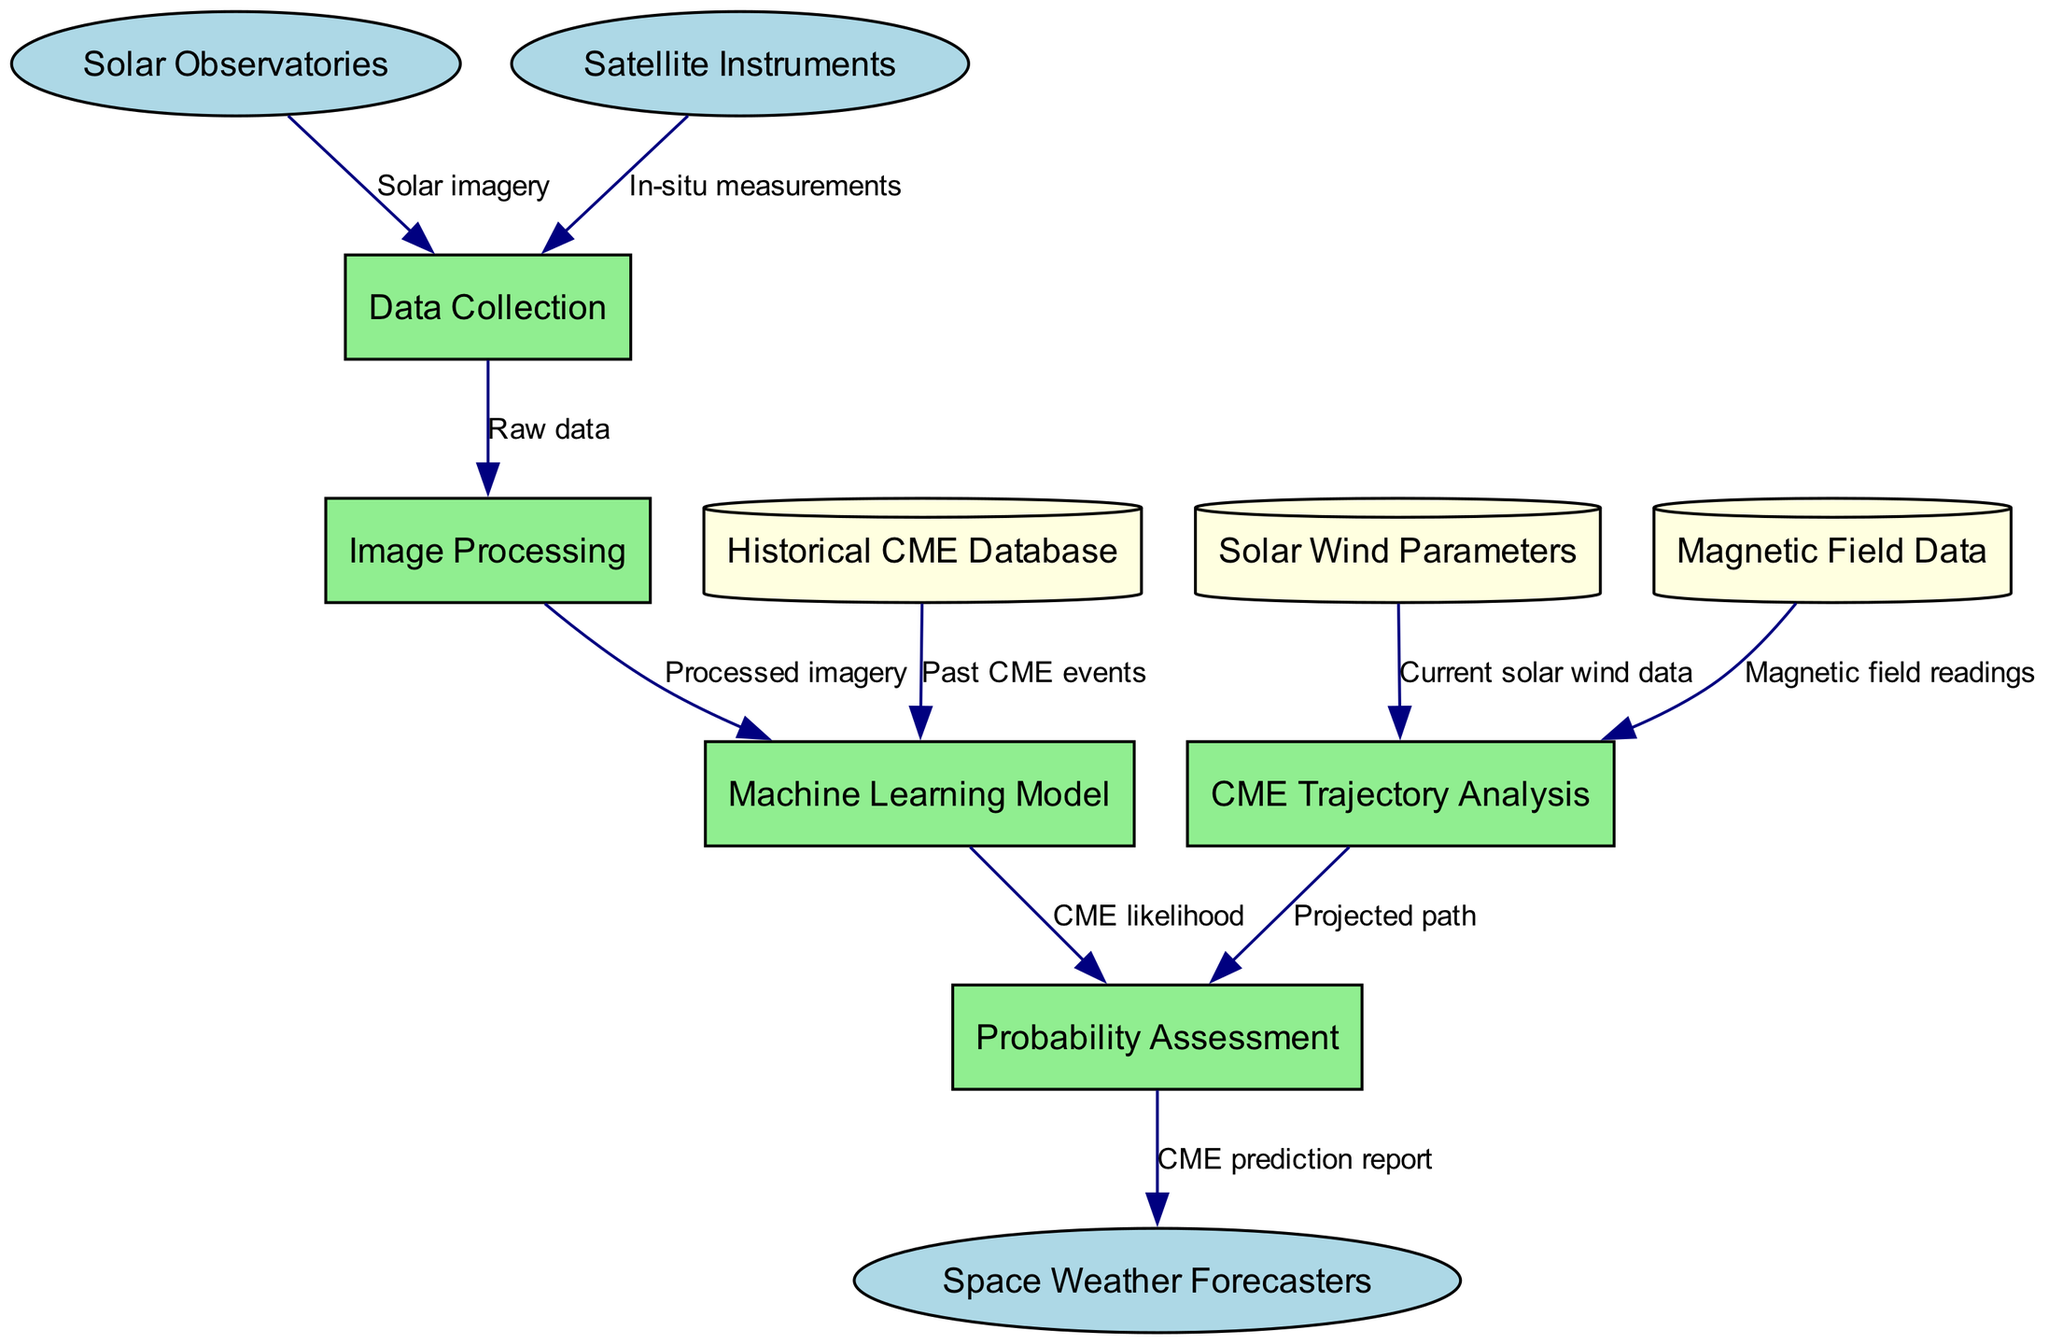What external entities are present in the diagram? The diagram lists three external entities: Solar Observatories, Satellite Instruments, and Space Weather Forecasters.
Answer: Solar Observatories, Satellite Instruments, Space Weather Forecasters What type of data flows from Satellite Instruments to Data Collection? The flow from Satellite Instruments to Data Collection is labeled as "In-situ measurements," indicating the type of data that is being transferred.
Answer: In-situ measurements How many processes are depicted in the diagram? There are five processes in the diagram: Data Collection, Image Processing, Machine Learning Model, CME Trajectory Analysis, and Probability Assessment, resulting in a total count of five.
Answer: 5 What data store provides "Past CME events" to the Machine Learning Model? The diagram shows that the Historical CME Database supplies "Past CME events" to the Machine Learning Model, indicating the source of this information.
Answer: Historical CME Database Which process receives input from both Solar Wind Parameters and Magnetic Field Data? The CME Trajectory Analysis process receives input from both Solar Wind Parameters and Magnetic Field Data, combining insights from these two sources for its analysis.
Answer: CME Trajectory Analysis What is the final output delivered to Space Weather Forecasters? The final output delivered to Space Weather Forecasters is labeled as "CME prediction report," which summarizes the predictions derived from previous analyses.
Answer: CME prediction report Describe the flow of data from Image Processing to Probability Assessment. The flow involves processed imagery from Image Processing being sent to the Machine Learning Model, which then contributes "CME likelihood" to the Probability Assessment process, highlighting the interconnected data processing.
Answer: Processed imagery, CME likelihood Which data flow is directly related to current solar wind conditions? The flow labeled as "Current solar wind data" is directed from Solar Wind Parameters to CME Trajectory Analysis, establishing its connection to real-time solar wind conditions.
Answer: Current solar wind data What role does the Machine Learning Model play in the diagram? The Machine Learning Model processes inputs from both the Image Processing and Historical CME Database to assess CME likelihood, indicating its importance in integrating various data inputs for prediction.
Answer: Assess CME likelihood 